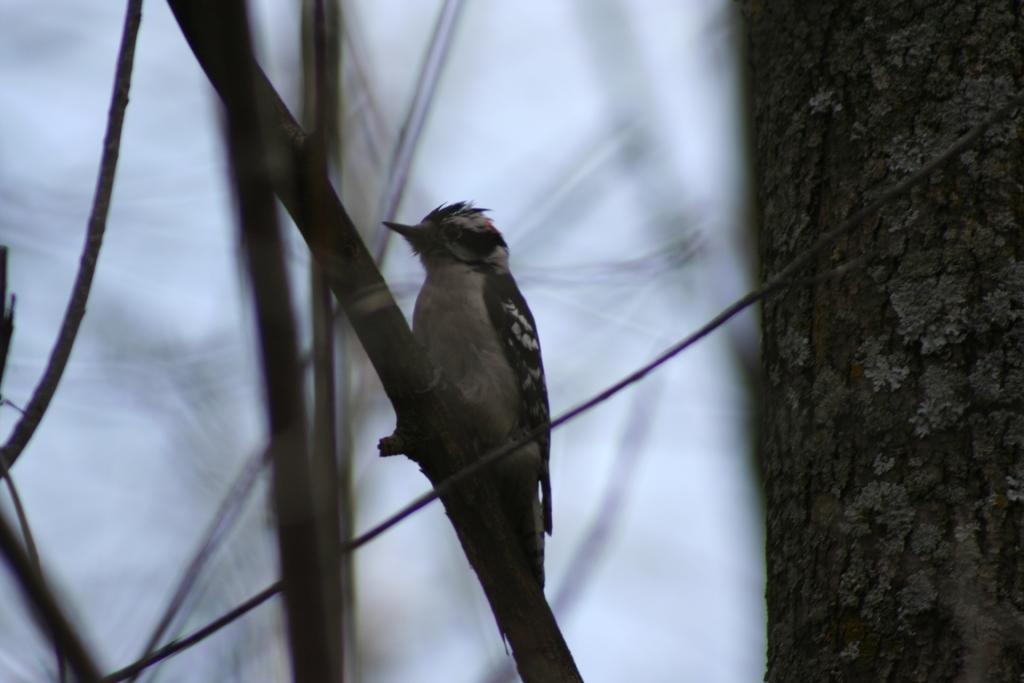What type of animal can be seen in the image? There is a bird in the image. Where is the bird located? The bird is on a tree or wooden sticks. What can be seen on the right side of the side of the image? There is a tree stem visible on the right side of the image. What is visible in the background of the image? The sky is visible in the background of the image. What type of horn can be seen on the bird in the image? There is no horn present on the bird in the image. What is the bird's interest in the idea of flying in the image? The image does not provide information about the bird's interests or ideas. 